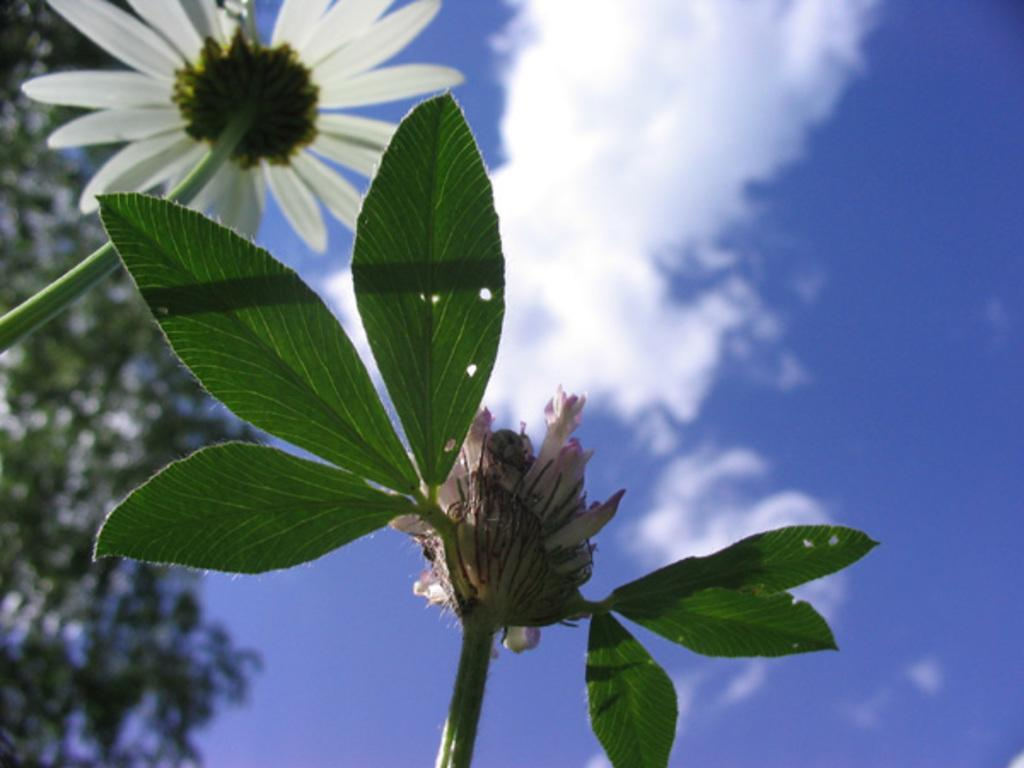What type of plants are in the image? The plants in the image have flowers on them. What can be seen in the background of the image? The sky is visible in the background of the image. What is the condition of the sky? Clouds are present in the sky. What type of brain structure can be seen in the image? There is no brain or brain structure present in the image; it features plants with flowers and a sky with clouds. 